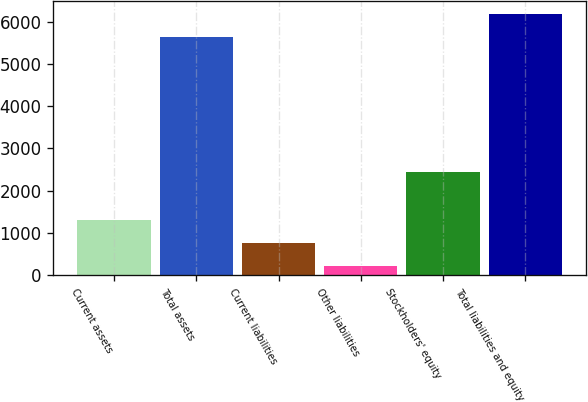Convert chart. <chart><loc_0><loc_0><loc_500><loc_500><bar_chart><fcel>Current assets<fcel>Total assets<fcel>Current liabilities<fcel>Other liabilities<fcel>Stockholders' equity<fcel>Total liabilities and equity<nl><fcel>1304.1<fcel>5640.9<fcel>762<fcel>219.9<fcel>2431.1<fcel>6183<nl></chart> 